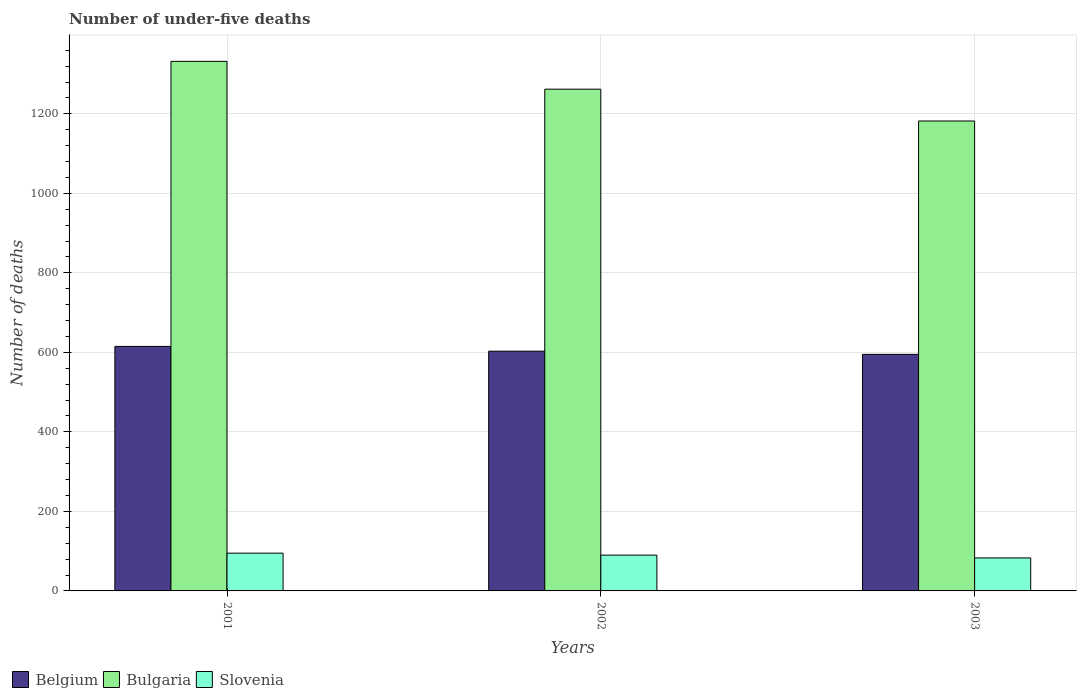Are the number of bars on each tick of the X-axis equal?
Make the answer very short. Yes. In how many cases, is the number of bars for a given year not equal to the number of legend labels?
Offer a terse response. 0. Across all years, what is the maximum number of under-five deaths in Slovenia?
Provide a short and direct response. 95. Across all years, what is the minimum number of under-five deaths in Slovenia?
Provide a succinct answer. 83. In which year was the number of under-five deaths in Slovenia minimum?
Ensure brevity in your answer.  2003. What is the total number of under-five deaths in Belgium in the graph?
Give a very brief answer. 1813. What is the difference between the number of under-five deaths in Belgium in 2001 and that in 2002?
Make the answer very short. 12. What is the difference between the number of under-five deaths in Belgium in 2003 and the number of under-five deaths in Bulgaria in 2002?
Provide a succinct answer. -667. What is the average number of under-five deaths in Slovenia per year?
Offer a terse response. 89.33. In the year 2003, what is the difference between the number of under-five deaths in Belgium and number of under-five deaths in Bulgaria?
Make the answer very short. -587. In how many years, is the number of under-five deaths in Bulgaria greater than 600?
Give a very brief answer. 3. What is the ratio of the number of under-five deaths in Slovenia in 2001 to that in 2003?
Provide a short and direct response. 1.14. Is the difference between the number of under-five deaths in Belgium in 2001 and 2002 greater than the difference between the number of under-five deaths in Bulgaria in 2001 and 2002?
Your answer should be very brief. No. What is the difference between the highest and the lowest number of under-five deaths in Belgium?
Offer a terse response. 20. In how many years, is the number of under-five deaths in Belgium greater than the average number of under-five deaths in Belgium taken over all years?
Make the answer very short. 1. What does the 2nd bar from the left in 2001 represents?
Offer a very short reply. Bulgaria. How many years are there in the graph?
Offer a terse response. 3. Are the values on the major ticks of Y-axis written in scientific E-notation?
Provide a short and direct response. No. Does the graph contain grids?
Give a very brief answer. Yes. How many legend labels are there?
Your answer should be compact. 3. How are the legend labels stacked?
Make the answer very short. Horizontal. What is the title of the graph?
Provide a succinct answer. Number of under-five deaths. Does "Guam" appear as one of the legend labels in the graph?
Give a very brief answer. No. What is the label or title of the Y-axis?
Keep it short and to the point. Number of deaths. What is the Number of deaths of Belgium in 2001?
Your answer should be very brief. 615. What is the Number of deaths of Bulgaria in 2001?
Keep it short and to the point. 1332. What is the Number of deaths of Belgium in 2002?
Make the answer very short. 603. What is the Number of deaths of Bulgaria in 2002?
Provide a short and direct response. 1262. What is the Number of deaths in Belgium in 2003?
Give a very brief answer. 595. What is the Number of deaths in Bulgaria in 2003?
Ensure brevity in your answer.  1182. Across all years, what is the maximum Number of deaths in Belgium?
Your response must be concise. 615. Across all years, what is the maximum Number of deaths of Bulgaria?
Offer a terse response. 1332. Across all years, what is the minimum Number of deaths of Belgium?
Make the answer very short. 595. Across all years, what is the minimum Number of deaths of Bulgaria?
Your answer should be very brief. 1182. What is the total Number of deaths of Belgium in the graph?
Offer a terse response. 1813. What is the total Number of deaths of Bulgaria in the graph?
Keep it short and to the point. 3776. What is the total Number of deaths in Slovenia in the graph?
Make the answer very short. 268. What is the difference between the Number of deaths of Belgium in 2001 and that in 2002?
Offer a terse response. 12. What is the difference between the Number of deaths in Bulgaria in 2001 and that in 2002?
Your answer should be compact. 70. What is the difference between the Number of deaths in Slovenia in 2001 and that in 2002?
Make the answer very short. 5. What is the difference between the Number of deaths in Belgium in 2001 and that in 2003?
Your answer should be very brief. 20. What is the difference between the Number of deaths in Bulgaria in 2001 and that in 2003?
Make the answer very short. 150. What is the difference between the Number of deaths in Belgium in 2002 and that in 2003?
Your answer should be very brief. 8. What is the difference between the Number of deaths in Bulgaria in 2002 and that in 2003?
Offer a very short reply. 80. What is the difference between the Number of deaths in Slovenia in 2002 and that in 2003?
Give a very brief answer. 7. What is the difference between the Number of deaths of Belgium in 2001 and the Number of deaths of Bulgaria in 2002?
Provide a succinct answer. -647. What is the difference between the Number of deaths of Belgium in 2001 and the Number of deaths of Slovenia in 2002?
Provide a short and direct response. 525. What is the difference between the Number of deaths in Bulgaria in 2001 and the Number of deaths in Slovenia in 2002?
Your response must be concise. 1242. What is the difference between the Number of deaths of Belgium in 2001 and the Number of deaths of Bulgaria in 2003?
Your response must be concise. -567. What is the difference between the Number of deaths of Belgium in 2001 and the Number of deaths of Slovenia in 2003?
Make the answer very short. 532. What is the difference between the Number of deaths in Bulgaria in 2001 and the Number of deaths in Slovenia in 2003?
Your answer should be very brief. 1249. What is the difference between the Number of deaths of Belgium in 2002 and the Number of deaths of Bulgaria in 2003?
Make the answer very short. -579. What is the difference between the Number of deaths of Belgium in 2002 and the Number of deaths of Slovenia in 2003?
Give a very brief answer. 520. What is the difference between the Number of deaths of Bulgaria in 2002 and the Number of deaths of Slovenia in 2003?
Give a very brief answer. 1179. What is the average Number of deaths of Belgium per year?
Offer a very short reply. 604.33. What is the average Number of deaths in Bulgaria per year?
Make the answer very short. 1258.67. What is the average Number of deaths of Slovenia per year?
Keep it short and to the point. 89.33. In the year 2001, what is the difference between the Number of deaths of Belgium and Number of deaths of Bulgaria?
Make the answer very short. -717. In the year 2001, what is the difference between the Number of deaths in Belgium and Number of deaths in Slovenia?
Ensure brevity in your answer.  520. In the year 2001, what is the difference between the Number of deaths in Bulgaria and Number of deaths in Slovenia?
Your answer should be very brief. 1237. In the year 2002, what is the difference between the Number of deaths in Belgium and Number of deaths in Bulgaria?
Your answer should be very brief. -659. In the year 2002, what is the difference between the Number of deaths in Belgium and Number of deaths in Slovenia?
Make the answer very short. 513. In the year 2002, what is the difference between the Number of deaths in Bulgaria and Number of deaths in Slovenia?
Your answer should be very brief. 1172. In the year 2003, what is the difference between the Number of deaths in Belgium and Number of deaths in Bulgaria?
Your answer should be compact. -587. In the year 2003, what is the difference between the Number of deaths in Belgium and Number of deaths in Slovenia?
Your answer should be compact. 512. In the year 2003, what is the difference between the Number of deaths in Bulgaria and Number of deaths in Slovenia?
Your answer should be compact. 1099. What is the ratio of the Number of deaths in Belgium in 2001 to that in 2002?
Provide a succinct answer. 1.02. What is the ratio of the Number of deaths of Bulgaria in 2001 to that in 2002?
Give a very brief answer. 1.06. What is the ratio of the Number of deaths of Slovenia in 2001 to that in 2002?
Offer a terse response. 1.06. What is the ratio of the Number of deaths of Belgium in 2001 to that in 2003?
Your answer should be compact. 1.03. What is the ratio of the Number of deaths in Bulgaria in 2001 to that in 2003?
Your response must be concise. 1.13. What is the ratio of the Number of deaths of Slovenia in 2001 to that in 2003?
Offer a very short reply. 1.14. What is the ratio of the Number of deaths in Belgium in 2002 to that in 2003?
Provide a short and direct response. 1.01. What is the ratio of the Number of deaths in Bulgaria in 2002 to that in 2003?
Your response must be concise. 1.07. What is the ratio of the Number of deaths of Slovenia in 2002 to that in 2003?
Your answer should be very brief. 1.08. What is the difference between the highest and the second highest Number of deaths in Belgium?
Provide a short and direct response. 12. What is the difference between the highest and the second highest Number of deaths in Bulgaria?
Your response must be concise. 70. What is the difference between the highest and the second highest Number of deaths in Slovenia?
Give a very brief answer. 5. What is the difference between the highest and the lowest Number of deaths in Bulgaria?
Offer a terse response. 150. What is the difference between the highest and the lowest Number of deaths in Slovenia?
Ensure brevity in your answer.  12. 